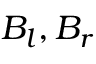Convert formula to latex. <formula><loc_0><loc_0><loc_500><loc_500>B _ { l } , B _ { r }</formula> 